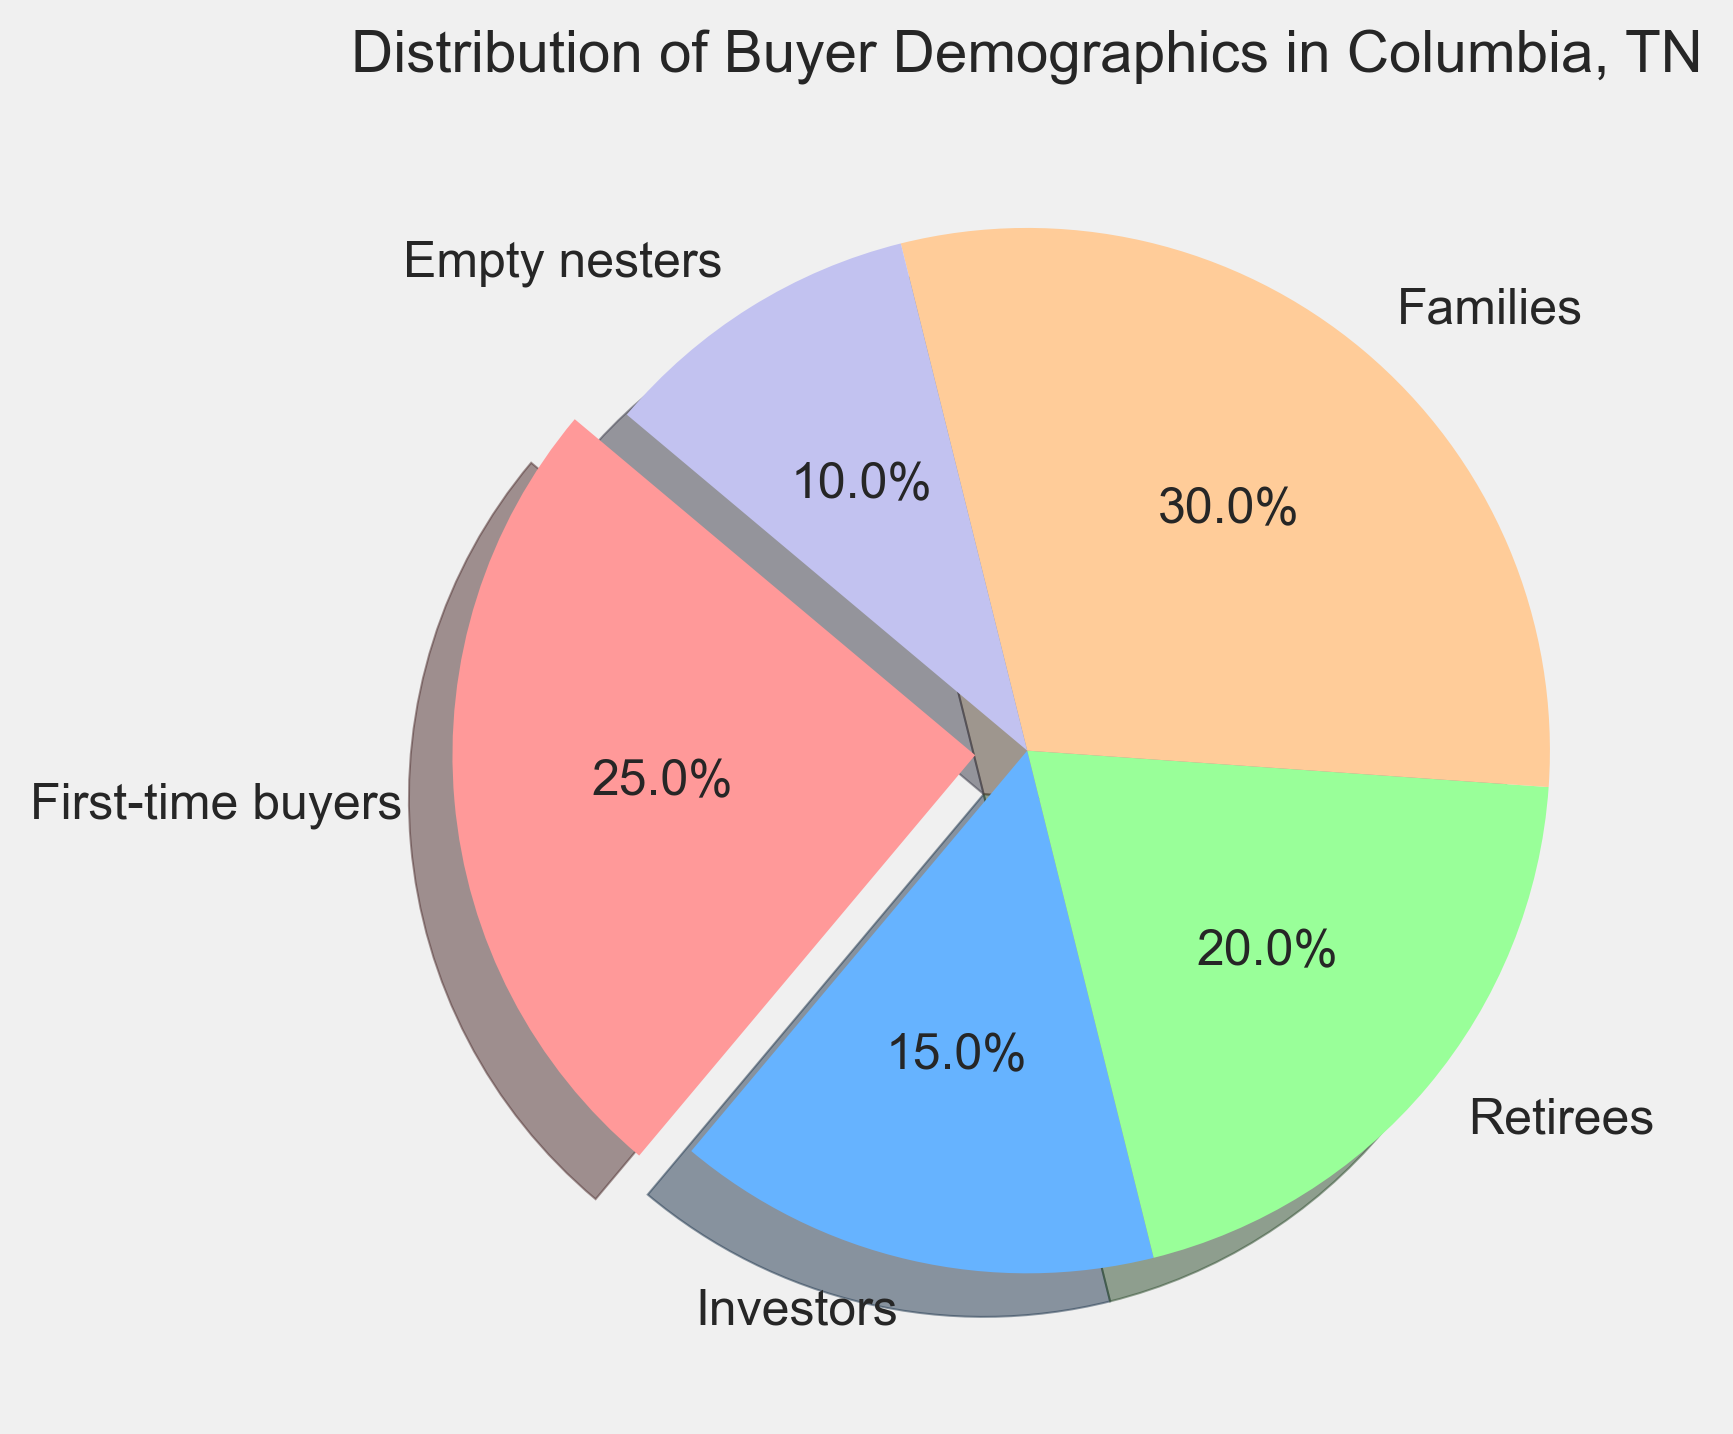Which demographic group has the highest percentage of buyers? By observing the pie chart, we can see that the "Families" slice is the largest. Therefore, "Families" has the highest percentage of buyers.
Answer: Families What is the combined percentage of "First-time buyers" and "Investors"? Adding the percentages of the "First-time buyers" (25%) and "Investors" (15%) segments gives us the total percentage. 25% + 15% = 40%
Answer: 40% How does the percentage of "Families" compare to "Retirees"? From the pie chart, "Families" are 30% and "Retirees" are 20%. Comparing these, 30% > 20%, so "Families" have a higher percentage than "Retirees".
Answer: Families have a higher percentage What color represents the "Empty nesters" group? By looking at the colors used in the pie chart legend, the "Empty nesters" slice is represented by a purple color.
Answer: Purple How much larger is the percentage of "First-time buyers" compared to "Empty nesters"? Subtracting the "Empty nesters" percentage (10%) from the "First-time buyers" percentage (25%) gives us the difference. 25% - 10% = 15%
Answer: 15% larger What is the difference in percentage between "Families" and "Investors"? Subtracting the "Investors" percentage (15%) from the "Families" percentage (30%) gives the difference. 30% - 15% = 15%
Answer: 15% What percentage of the buyers are "Retirees" and "Empty nesters" together? Adding the "Retirees" percentage (20%) and the "Empty nesters" percentage (10%) gives the combined total. 20% + 10% = 30%
Answer: 30% Which demographic group has the smallest percentage of buyers? By observing the pie chart, we can see that the "Empty nesters" slice is the smallest. Therefore, "Empty nesters" has the smallest percentage of buyers.
Answer: Empty nesters Is the percentage of "Families" more than twice the percentage of "Investors"? To determine this, we calculate twice the percentage of "Investors" (15% * 2 = 30%) and compare it to the percentage of "Families" (30%). Both are equal, hence the percentage of "Families" is not more than twice "Investors".
Answer: No, they are the same If "Retirees" and "Investors" were combined into one group, what would be their new percentage? Combining "Retirees" (20%) and "Investors" (15%) gives us a total percentage of 35%. 20% + 15% = 35%
Answer: 35% 